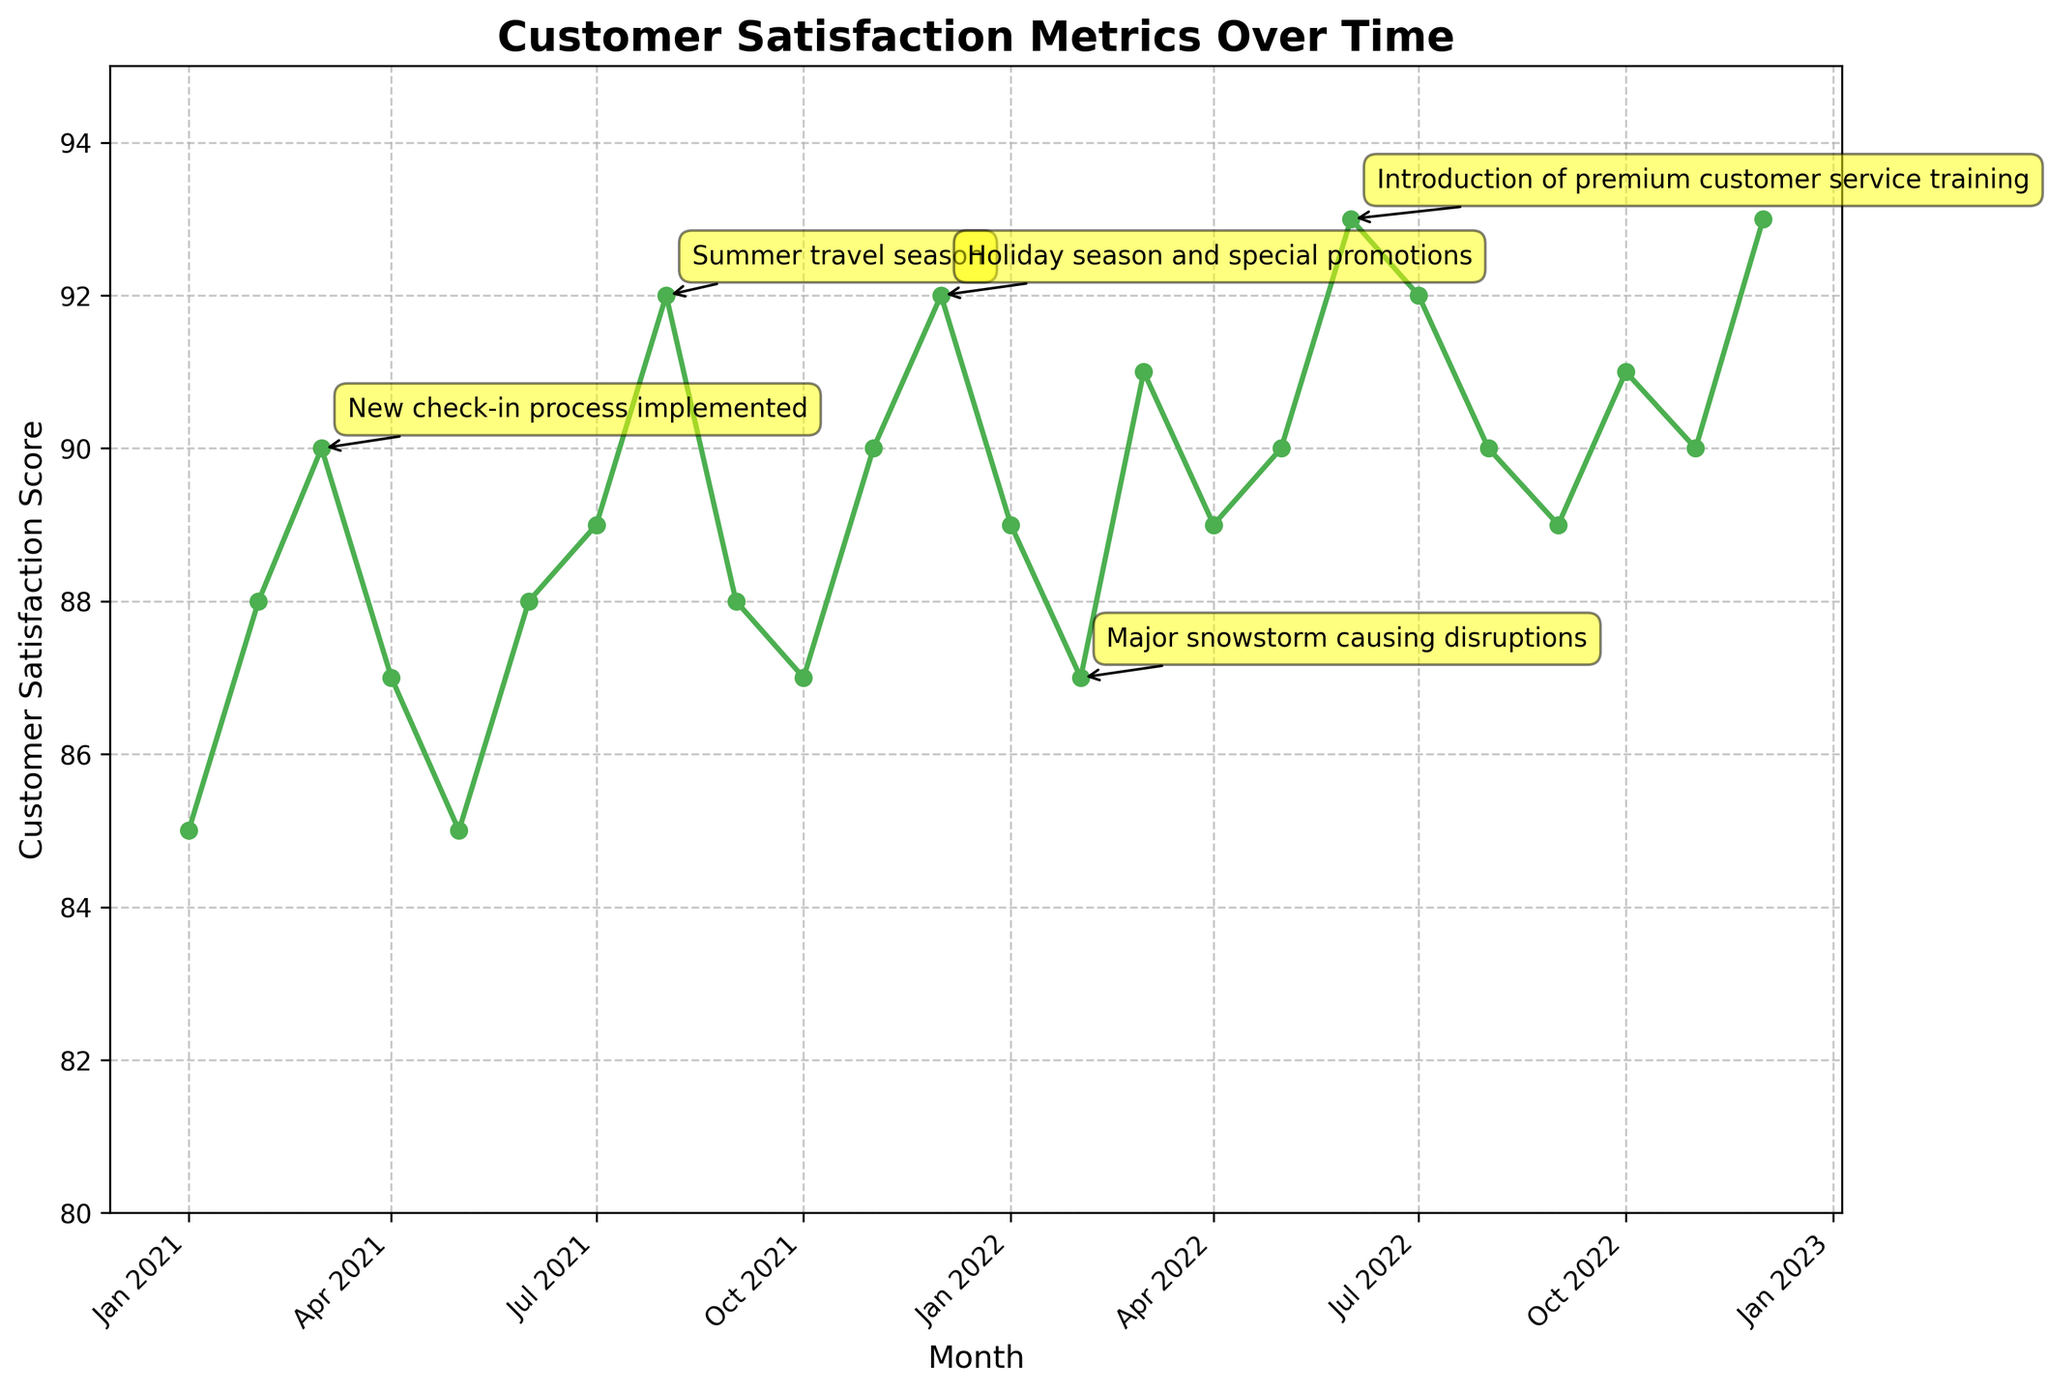What is the highest customer satisfaction score recorded? By examining the line chart, we identify the maximum value on the y-axis, which is represented by the highest point on the curve. Looking at the data points, the highest score is 93.
Answer: 93 In which month did customer satisfaction drop due to a new check-in process? Referring to the annotations on the diagram, we see that March 2021 is highlighted as the month when the new check-in process was implemented, resulting in a minor drop in satisfaction.
Answer: March 2021 What was the customer satisfaction score in December 2022? We can find the score for December 2022 by looking at the corresponding point on the chart, which indicates a value of 93 for that month.
Answer: 93 Which month saw an increase in satisfaction due to the summer travel season? The annotations reveal that August 2021 was marked as a significant month with increased satisfaction attributed to the summer travel season.
Answer: August 2021 What was the customer satisfaction score trend from January 2021 to June 2021? Analyzing the data points for this period, we see scores of 85, 88, 90, 87, 85, and 88, indicating a fluctuating trend with a slight increase followed by a drop.
Answer: Fluctuating trend What event caused a slight drop in satisfaction in February 2022? The annotations indicate that a major snowstorm caused disruptions in February 2022, contributing to a slight decrease in customer satisfaction.
Answer: Major snowstorm How many significant events are annotated on the diagram? By counting the annotations provided in the data, there are five key events specifically highlighted that impact customer satisfaction scores over time.
Answer: Five What is the score for customer satisfaction in September 2022? Looking at the data for September 2022 within the diagram details, the corresponding customer satisfaction score is noted to be 89.
Answer: 89 Which event is associated with improved satisfaction due to better service quality? The training for premium customer service introduced in June 2022 is specifically noted as the event that led to improved customer satisfaction scores.
Answer: Introduction of premium customer service training 